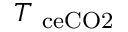Convert formula to latex. <formula><loc_0><loc_0><loc_500><loc_500>T _ { \ c e { C O 2 } }</formula> 